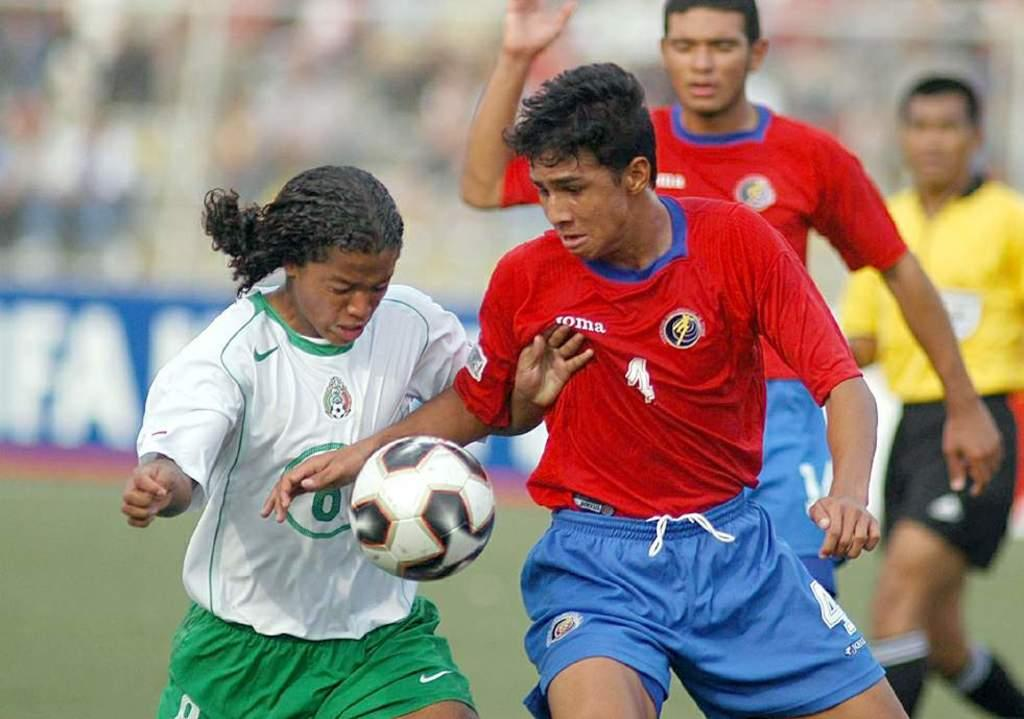<image>
Create a compact narrative representing the image presented. the number 4 is on the shorts of the person 